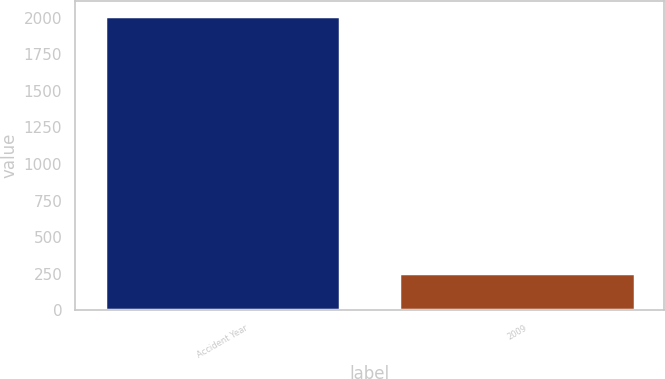<chart> <loc_0><loc_0><loc_500><loc_500><bar_chart><fcel>Accident Year<fcel>2009<nl><fcel>2012<fcel>256<nl></chart> 